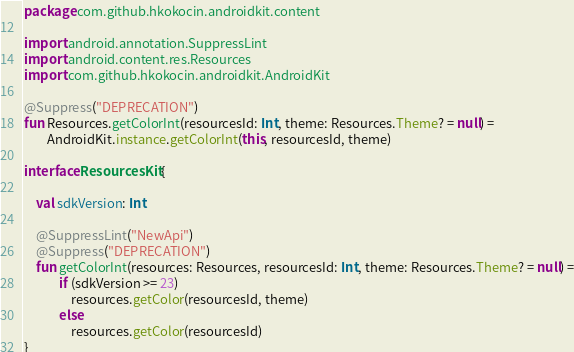Convert code to text. <code><loc_0><loc_0><loc_500><loc_500><_Kotlin_>package com.github.hkokocin.androidkit.content

import android.annotation.SuppressLint
import android.content.res.Resources
import com.github.hkokocin.androidkit.AndroidKit

@Suppress("DEPRECATION")
fun Resources.getColorInt(resourcesId: Int, theme: Resources.Theme? = null) =
        AndroidKit.instance.getColorInt(this, resourcesId, theme)

interface ResourcesKit {

    val sdkVersion: Int

    @SuppressLint("NewApi")
    @Suppress("DEPRECATION")
    fun getColorInt(resources: Resources, resourcesId: Int, theme: Resources.Theme? = null) =
            if (sdkVersion >= 23)
                resources.getColor(resourcesId, theme)
            else
                resources.getColor(resourcesId)
}</code> 